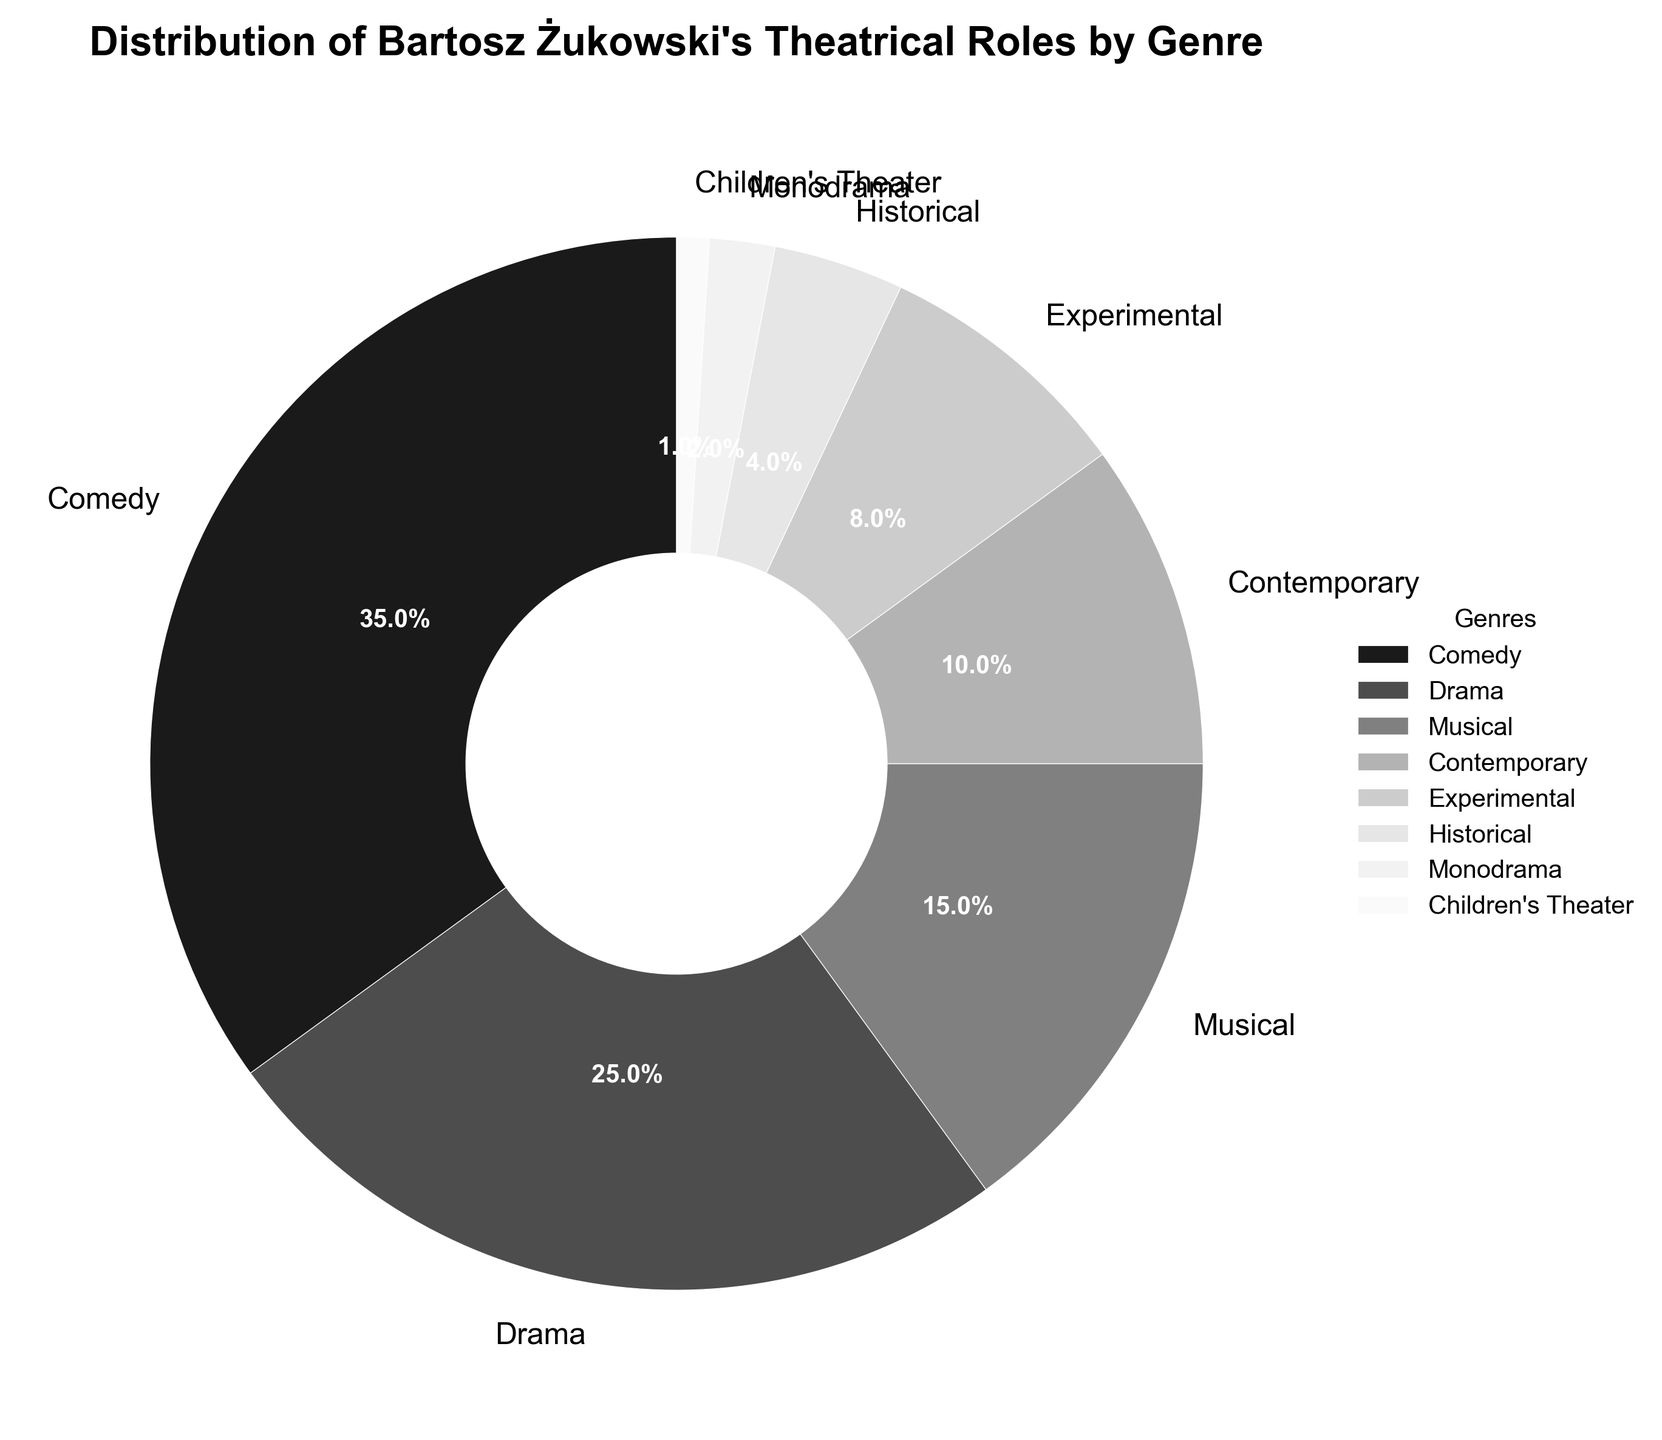What percentage of Bartosz Żukowski's roles are in Drama? Locate the Drama section on the pie chart and read its corresponding percentage label.
Answer: 25% What are the combined percentages of Bartosz's roles in Musical and Contemporary genres? Add the percentages of Musical and Contemporary from the pie chart. Musical is 15% and Contemporary is 10%. So, 15% + 10% = 25%.
Answer: 25% Which genre has the least representation in Bartosz Żukowski's theatrical roles? Find the smallest percentage on the pie chart. The smallest percentage is Children's Theater with 1%.
Answer: Children's Theater How does the percentage of roles in Comedy compare to Drama? Note the percentages of Comedy (35%) and Drama (25%). Since 35% is greater than 25%, Comedy has a higher percentage than Drama.
Answer: Comedy has a higher percentage What is the difference in percentage between Experimental and Historical roles? Subtract the percentage for Historical (4%) from the percentage for Experimental (8%). So, 8% - 4% = 4%.
Answer: 4% If you combine the percentages of Comedy, Drama, and Musical roles, what total percentage do you get? Sum the percentages for Comedy (35%), Drama (25%), and Musical (15%). Therefore, 35% + 25% + 15% = 75%.
Answer: 75% Are there more roles in Experimental or Monodrama for Bartosz Żukowski? Compare the percentages of Experimental (8%) and Monodrama (2%). Since 8% is greater than 2%, the Experimental genre has more roles.
Answer: Experimental Which genre has a smaller percentage: Contemporary or Historical? Compare the percentages for Contemporary (10%) and Historical (4%). Since 4% is smaller than 10%, Historical has a smaller percentage.
Answer: Historical What is the combined percentage of all genres except Comedy? Sum the percentages of all genres except Comedy (35%). The other genres are: Drama (25%), Musical (15%), Contemporary (10%), Experimental (8%), Historical (4%), Monodrama (2%), Children's Theater (1%). Therefore, 25% + 15% + 10% + 8% + 4% + 2% + 1% = 65%.
Answer: 65% Between Musical and Experimental, which genre has a greater percentage and by how much? Compare Musical (15%) and Experimental (8%). The difference is 15% - 8% = 7%. Musical has a greater percentage by 7%.
Answer: Musical by 7% 